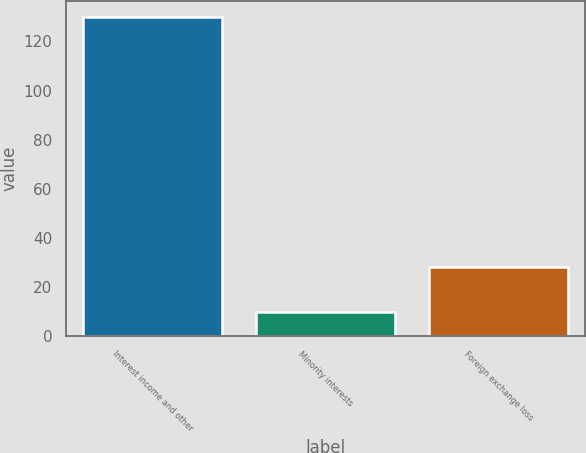Convert chart. <chart><loc_0><loc_0><loc_500><loc_500><bar_chart><fcel>Interest income and other<fcel>Minority interests<fcel>Foreign exchange loss<nl><fcel>130<fcel>10<fcel>28<nl></chart> 